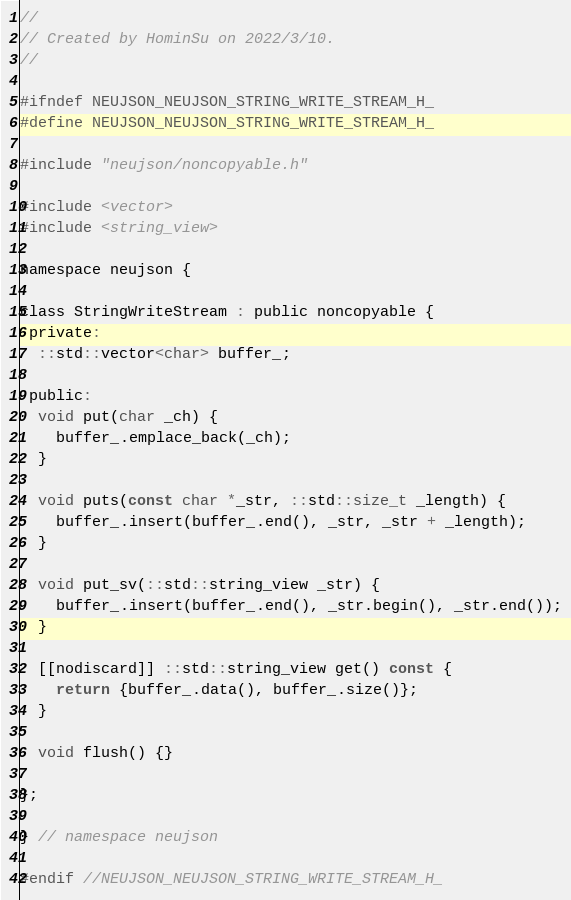Convert code to text. <code><loc_0><loc_0><loc_500><loc_500><_C_>//
// Created by HominSu on 2022/3/10.
//

#ifndef NEUJSON_NEUJSON_STRING_WRITE_STREAM_H_
#define NEUJSON_NEUJSON_STRING_WRITE_STREAM_H_

#include "neujson/noncopyable.h"

#include <vector>
#include <string_view>

namespace neujson {

class StringWriteStream : public noncopyable {
 private:
  ::std::vector<char> buffer_;

 public:
  void put(char _ch) {
    buffer_.emplace_back(_ch);
  }

  void puts(const char *_str, ::std::size_t _length) {
    buffer_.insert(buffer_.end(), _str, _str + _length);
  }

  void put_sv(::std::string_view _str) {
    buffer_.insert(buffer_.end(), _str.begin(), _str.end());
  }

  [[nodiscard]] ::std::string_view get() const {
    return {buffer_.data(), buffer_.size()};
  }

  void flush() {}

};

} // namespace neujson

#endif //NEUJSON_NEUJSON_STRING_WRITE_STREAM_H_
</code> 